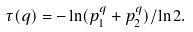<formula> <loc_0><loc_0><loc_500><loc_500>\tau ( q ) = - \ln ( p _ { 1 } ^ { q } + p _ { 2 } ^ { q } ) / \ln 2 .</formula> 